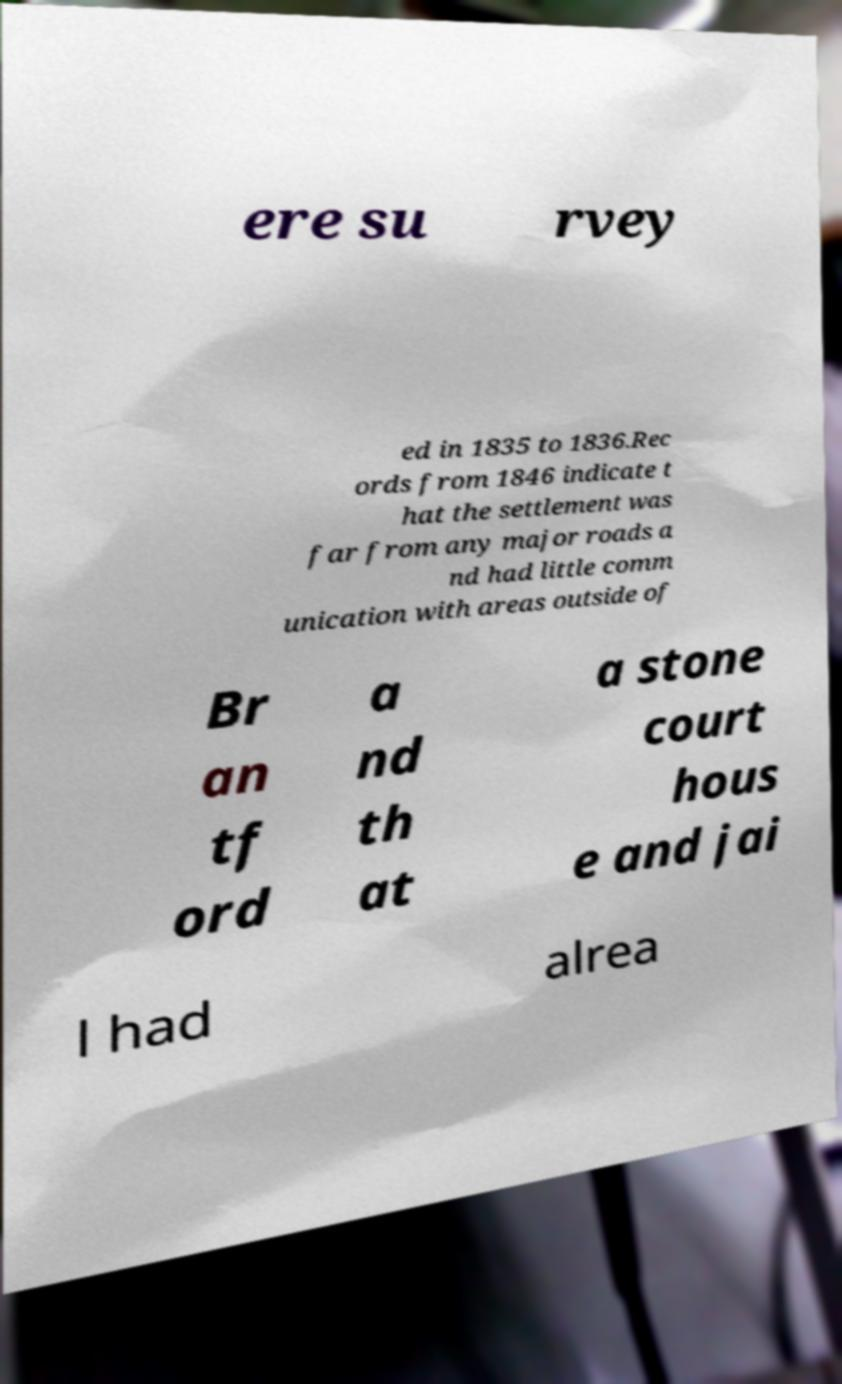I need the written content from this picture converted into text. Can you do that? ere su rvey ed in 1835 to 1836.Rec ords from 1846 indicate t hat the settlement was far from any major roads a nd had little comm unication with areas outside of Br an tf ord a nd th at a stone court hous e and jai l had alrea 